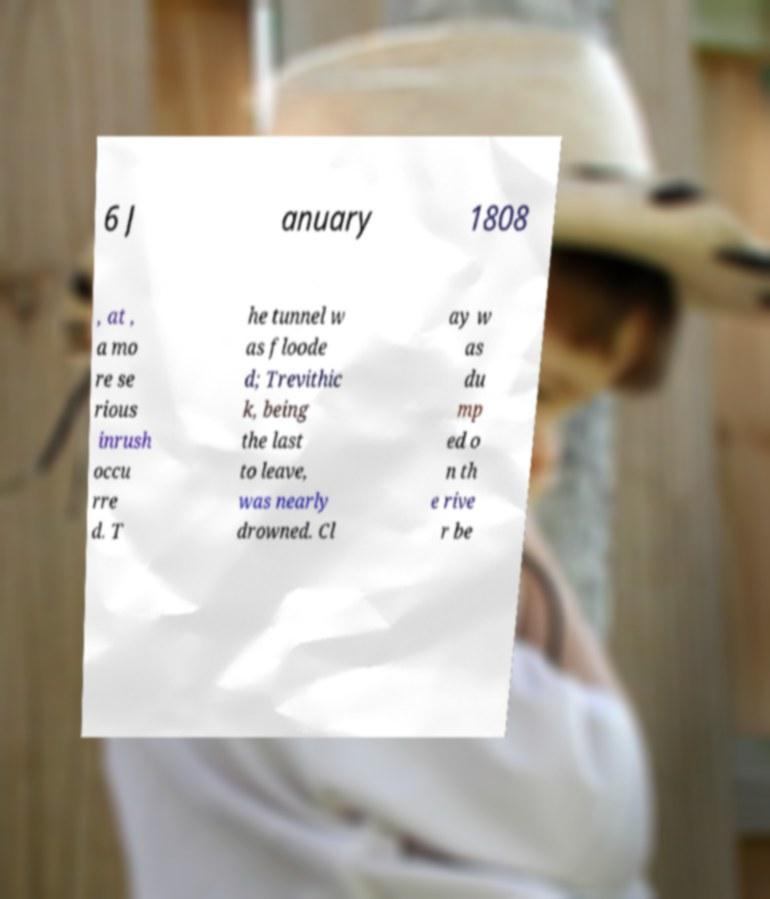Could you extract and type out the text from this image? 6 J anuary 1808 , at , a mo re se rious inrush occu rre d. T he tunnel w as floode d; Trevithic k, being the last to leave, was nearly drowned. Cl ay w as du mp ed o n th e rive r be 